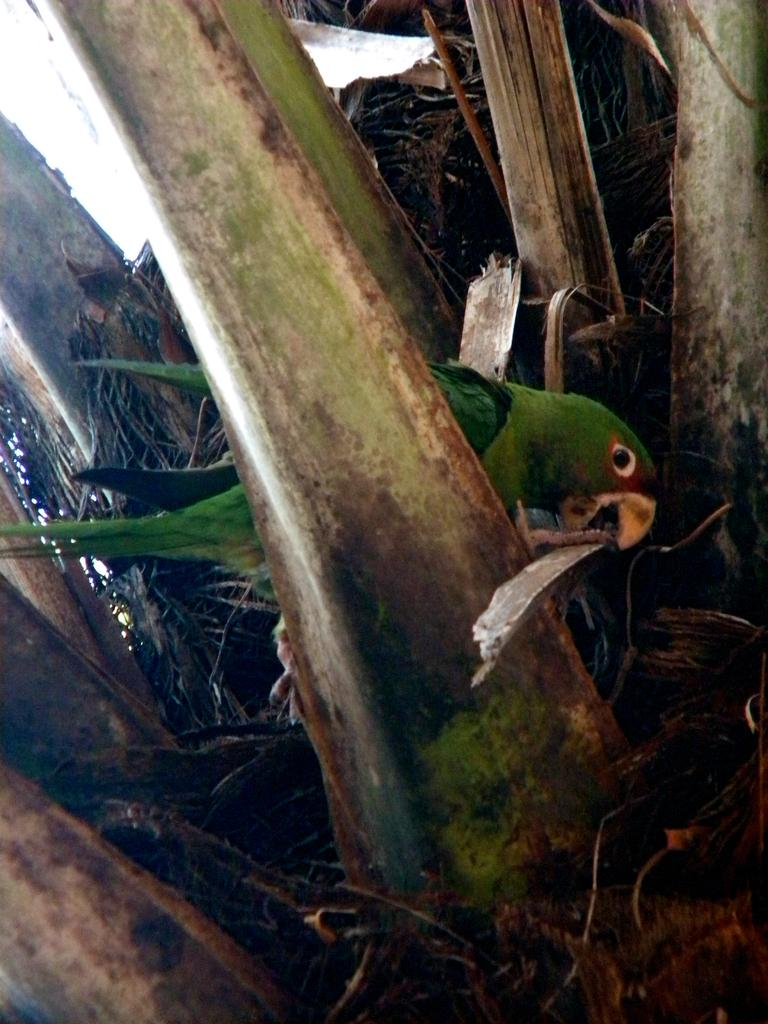What type of animal can be seen in the image? There is a bird in the image. Where is the bird located? The bird is sitting on a dry tree trunk. What type of building can be seen in the background of the image? There is no building present in the image; it only features a bird sitting on a dry tree trunk. 